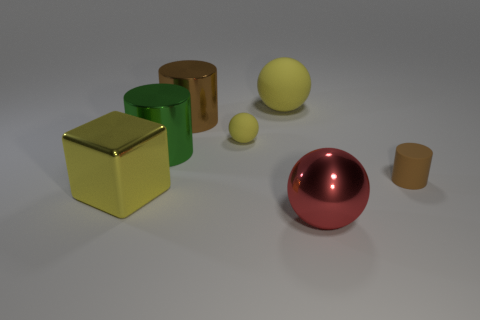Subtract 3 balls. How many balls are left? 0 Add 2 big green cylinders. How many objects exist? 9 Subtract all yellow balls. How many balls are left? 1 Add 1 big spheres. How many big spheres are left? 3 Add 3 large blue rubber blocks. How many large blue rubber blocks exist? 3 Subtract all yellow balls. How many balls are left? 1 Subtract 1 yellow blocks. How many objects are left? 6 Subtract all spheres. How many objects are left? 4 Subtract all red spheres. Subtract all purple blocks. How many spheres are left? 2 Subtract all cyan cubes. How many cyan cylinders are left? 0 